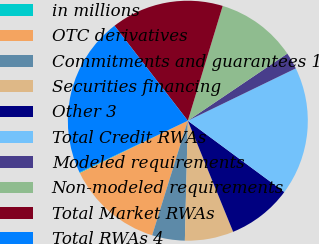<chart> <loc_0><loc_0><loc_500><loc_500><pie_chart><fcel>in millions<fcel>OTC derivatives<fcel>Commitments and guarantees 1<fcel>Securities financing<fcel>Other 3<fcel>Total Credit RWAs<fcel>Modeled requirements<fcel>Non-modeled requirements<fcel>Total Market RWAs<fcel>Total RWAs 4<nl><fcel>0.11%<fcel>13.01%<fcel>4.41%<fcel>6.56%<fcel>8.71%<fcel>17.31%<fcel>2.26%<fcel>10.86%<fcel>15.16%<fcel>21.61%<nl></chart> 